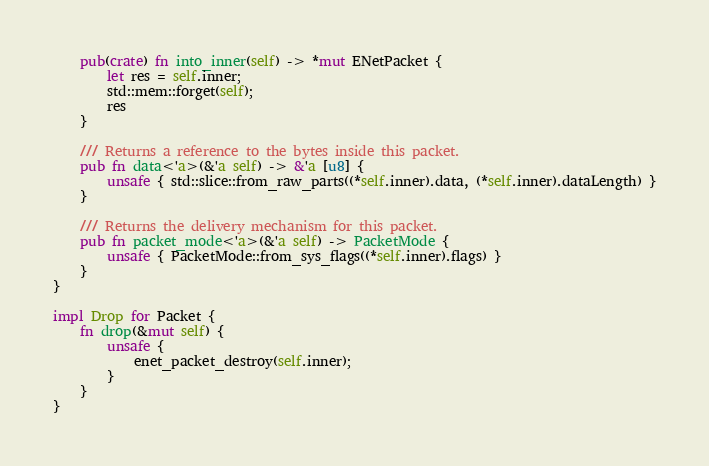Convert code to text. <code><loc_0><loc_0><loc_500><loc_500><_Rust_>    pub(crate) fn into_inner(self) -> *mut ENetPacket {
        let res = self.inner;
        std::mem::forget(self);
        res
    }

    /// Returns a reference to the bytes inside this packet.
    pub fn data<'a>(&'a self) -> &'a [u8] {
        unsafe { std::slice::from_raw_parts((*self.inner).data, (*self.inner).dataLength) }
    }

    /// Returns the delivery mechanism for this packet.
    pub fn packet_mode<'a>(&'a self) -> PacketMode {
        unsafe { PacketMode::from_sys_flags((*self.inner).flags) }
    }
}

impl Drop for Packet {
    fn drop(&mut self) {
        unsafe {
            enet_packet_destroy(self.inner);
        }
    }
}
</code> 